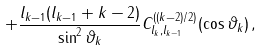Convert formula to latex. <formula><loc_0><loc_0><loc_500><loc_500>+ \frac { l _ { k - 1 } ( l _ { k - 1 } + k - 2 ) } { \sin ^ { 2 } \vartheta _ { k } } C _ { l _ { k } , l _ { k - 1 } } ^ { ( ( k - 2 ) / 2 ) } ( \cos \vartheta _ { k } ) \, ,</formula> 